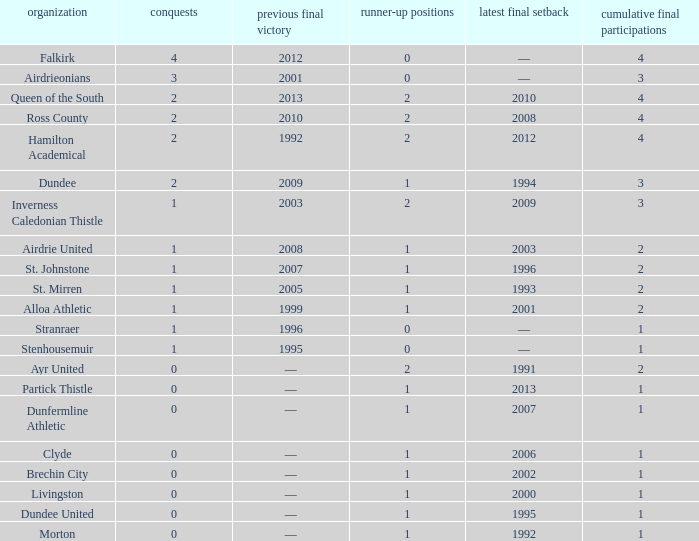How manywins for dunfermline athletic that has a total final appearances less than 2? 0.0. 